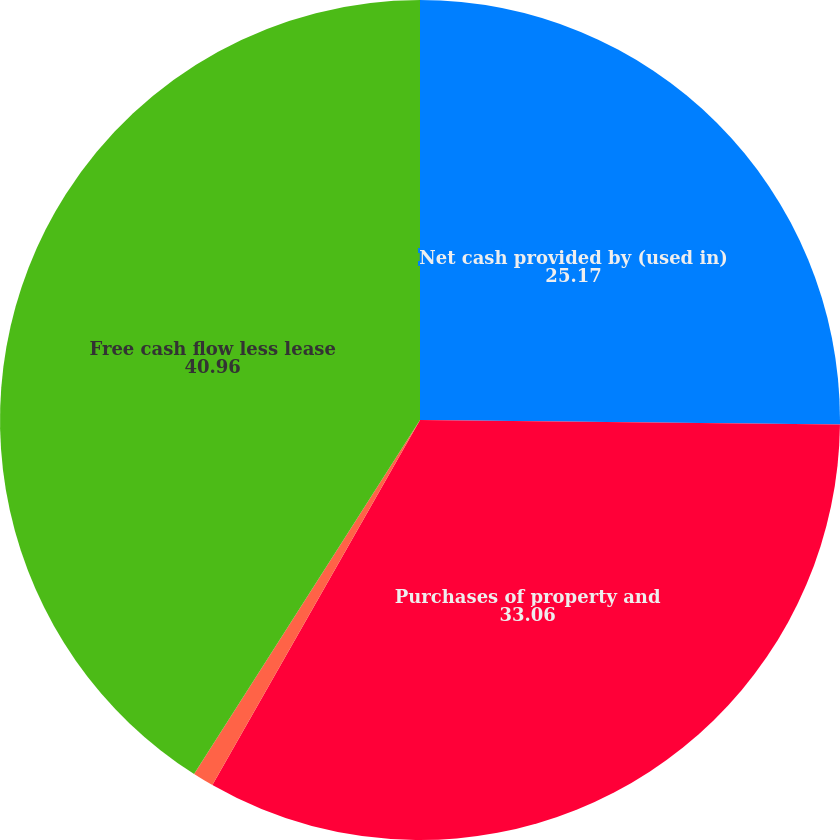<chart> <loc_0><loc_0><loc_500><loc_500><pie_chart><fcel>Net cash provided by (used in)<fcel>Purchases of property and<fcel>Principal repayments of<fcel>Free cash flow less lease<nl><fcel>25.17%<fcel>33.06%<fcel>0.81%<fcel>40.96%<nl></chart> 